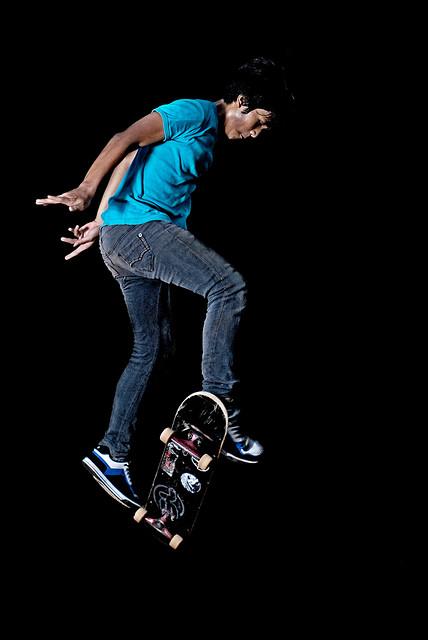What is the boy doing?
Write a very short answer. Skateboarding. Is this person on the ground?
Give a very brief answer. No. What is the word on the snowboard?
Write a very short answer. None. What color is he mainly wearing?
Quick response, please. Blue. 